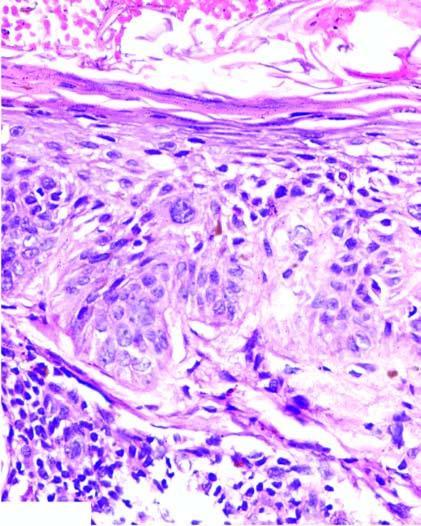s glomerular tufts effaced?
Answer the question using a single word or phrase. No 